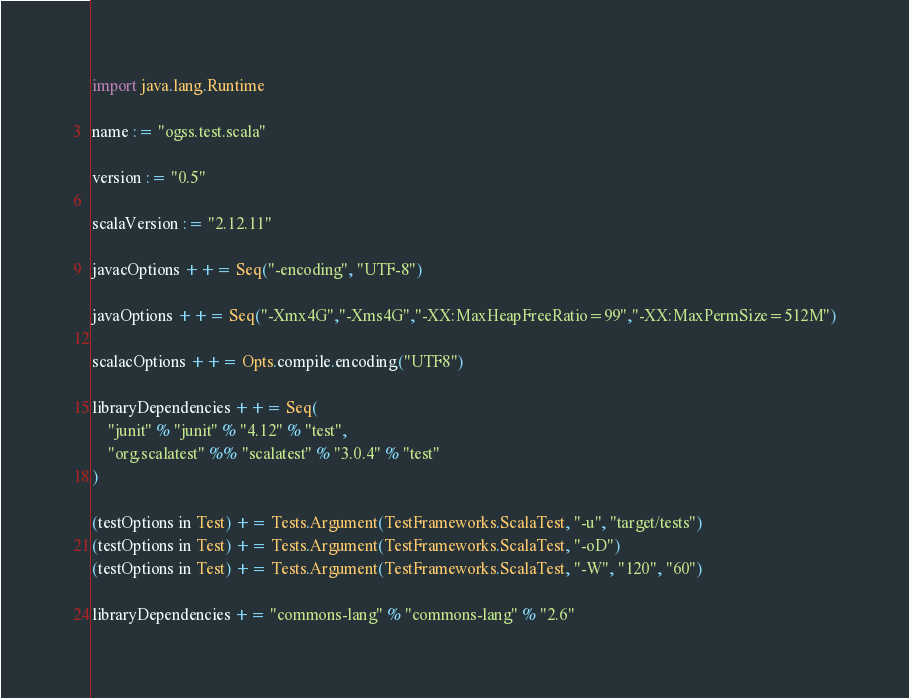Convert code to text. <code><loc_0><loc_0><loc_500><loc_500><_Scala_>import java.lang.Runtime

name := "ogss.test.scala"

version := "0.5"

scalaVersion := "2.12.11"

javacOptions ++= Seq("-encoding", "UTF-8")

javaOptions ++= Seq("-Xmx4G","-Xms4G","-XX:MaxHeapFreeRatio=99","-XX:MaxPermSize=512M")

scalacOptions ++= Opts.compile.encoding("UTF8")

libraryDependencies ++= Seq(
	"junit" % "junit" % "4.12" % "test",
    "org.scalatest" %% "scalatest" % "3.0.4" % "test"
)

(testOptions in Test) += Tests.Argument(TestFrameworks.ScalaTest, "-u", "target/tests")
(testOptions in Test) += Tests.Argument(TestFrameworks.ScalaTest, "-oD")
(testOptions in Test) += Tests.Argument(TestFrameworks.ScalaTest, "-W", "120", "60")

libraryDependencies += "commons-lang" % "commons-lang" % "2.6"
</code> 